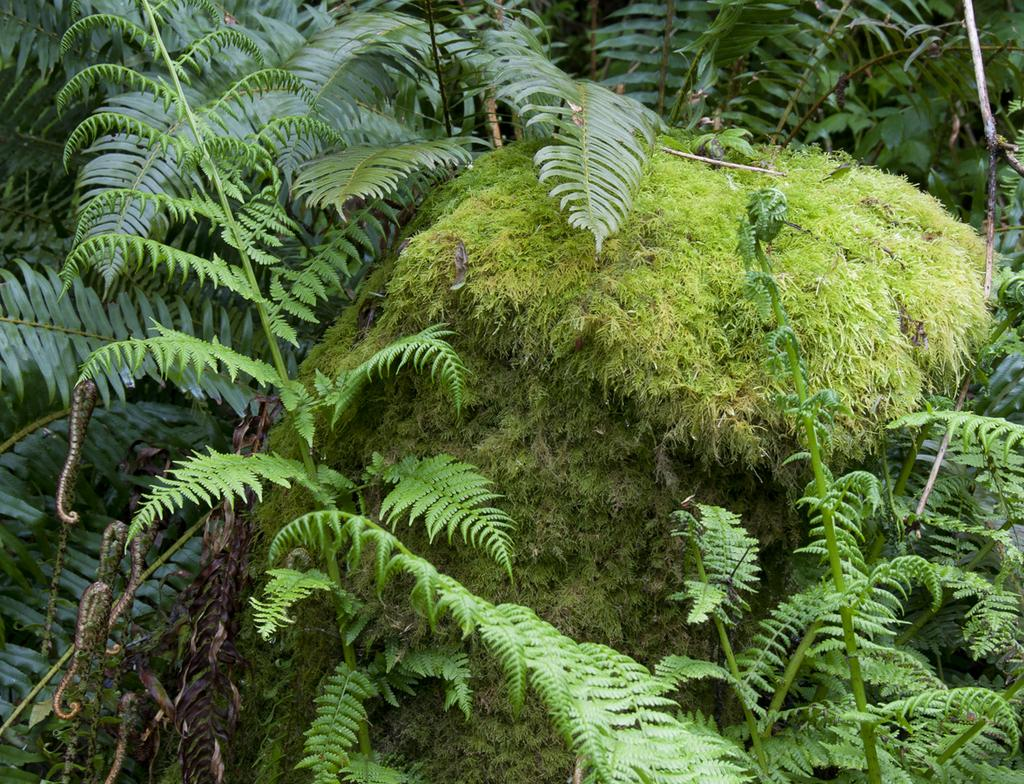Where was the image taken? The image was taken outdoors. What can be seen in the image besides the outdoor setting? There are plants in the image. What is the color of the leaves on the plants? The leaves on the plants are green. What other parts of the plants can be observed? The plants have stems and branches. What else is present in the image? There is a heap of grass in the image. What type of oven can be seen in the image? There is no oven present in the image. How many bells are hanging from the branches of the plants? There are no bells present in the image; the plants have leaves, stems, and branches. 